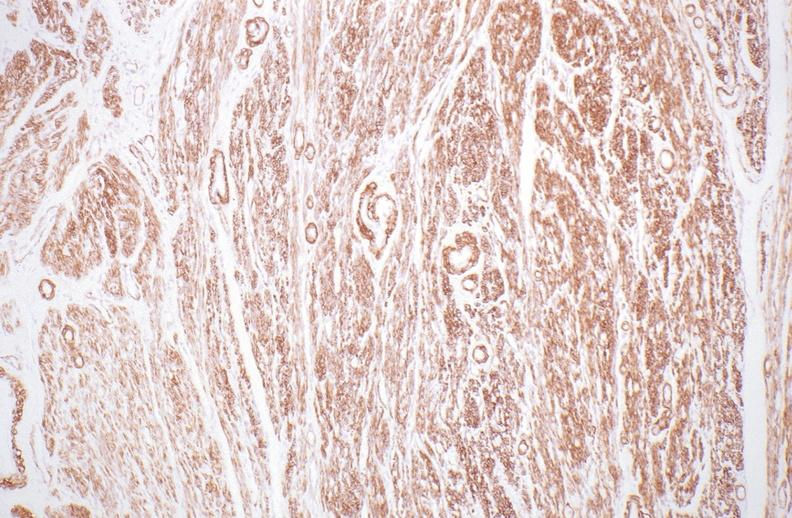does this show normal uterus?
Answer the question using a single word or phrase. No 